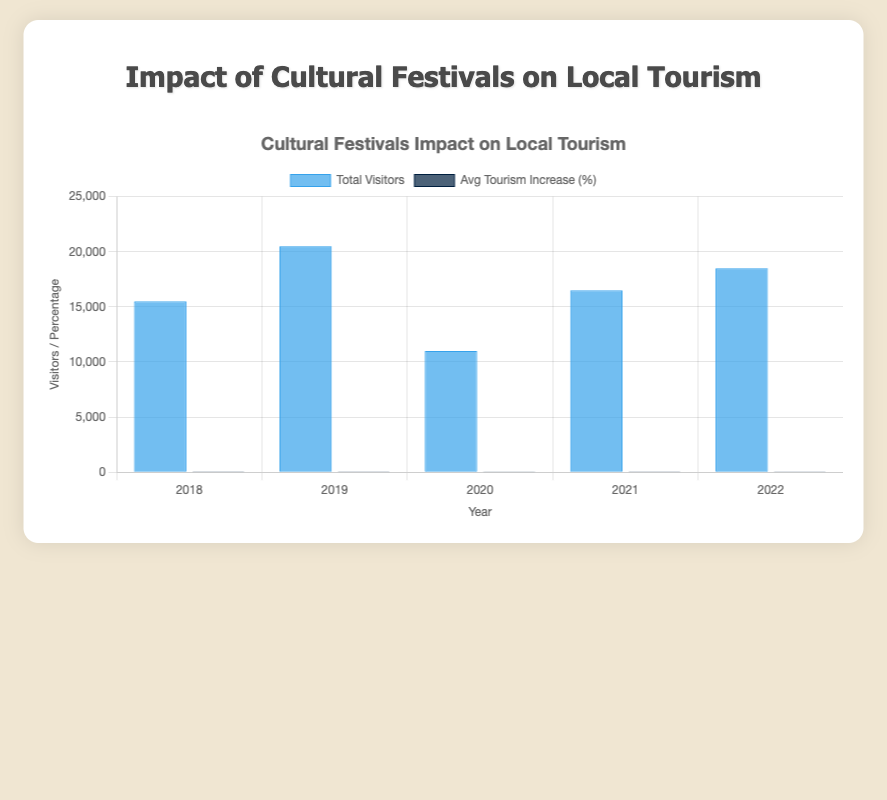What was the total number of visitors in 2022? The visitor data for 2022 is the sum of the visitors from the Sami Winter Market and the Amazon Rainforest Festival: 10,000 + 8,500 = 18,500
Answer: 18,500 Which year saw the highest average tourism increase percentage? From the chart, we compare the average tourism increase percentages for all years and find that 2022 had the highest at 24.5%
Answer: 2022 In which year did the total visitors exceed 15,000 for the first time? Looking at the bar chart, the first instance where the total visitors exceeded 15,000 is in 2019
Answer: 2019 By how much did the average tourism increase percentage rise from 2020 to 2021? The average increase in tourism for 2020 was 13%. For 2021, it was 21.5%. The rise is 21.5% - 13% = 8.5%
Answer: 8.5% What was the lowest total visitor count recorded, and in which year? The year with the lowest total visitor count is 2020, with summed visitors from two festivals of 5,000 and 6,000, totaling 11,000
Answer: 2020 Which color represents the average tourism increase percentage? The chart indicates that the bars representing the average tourism increase percentages are in dark blue
Answer: Dark blue How do the total visitor counts in 2018 compare to 2020? In 2018, the total visitors sum to 7,000 + 8,500 = 15,500. For 2020, the total is 5,000 + 6,000 = 11,000. Comparing, 15,500 is greater than 11,000
Answer: 2018 is greater What is the average total visitors over the years displayed? Sum the total visitors for each year and divide by the number of years: (15,500 + 20,500 + 11,000 + 16,500 + 18,500) / 5 = 16,000
Answer: 16,000 Between 2018 and 2019, did the average tourism increase percentage grow by more than 5%? The average tourism increase in 2018 was 18.5%, in 2019 it was 21.5%. The increase is 21.5% - 18.5% = 3%, which is not more than 5%
Answer: No, it did not 